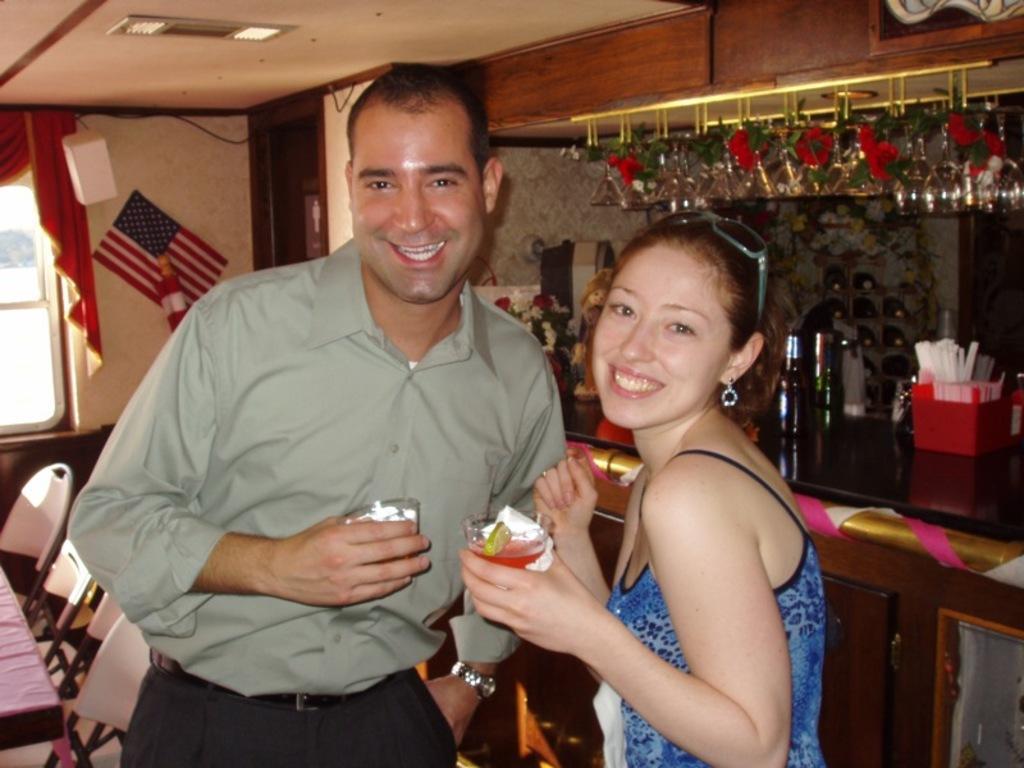Could you give a brief overview of what you see in this image? In this image, there are a few people holding some objects. We can see a table with some objects like bottles and flowers. We can also see some glasses. We can also see the wall with some objects and a poster. We can also see the window and some curtains. We can also see the roof with some lights. 